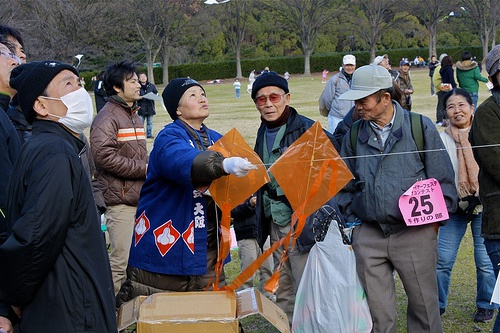Describe the objects in this image and their specific colors. I can see people in gray, black, lavender, and darkgray tones, people in gray, black, and darkblue tones, people in gray, black, navy, and darkgray tones, people in gray, black, darkgray, and tan tones, and people in gray, black, and darkgray tones in this image. 